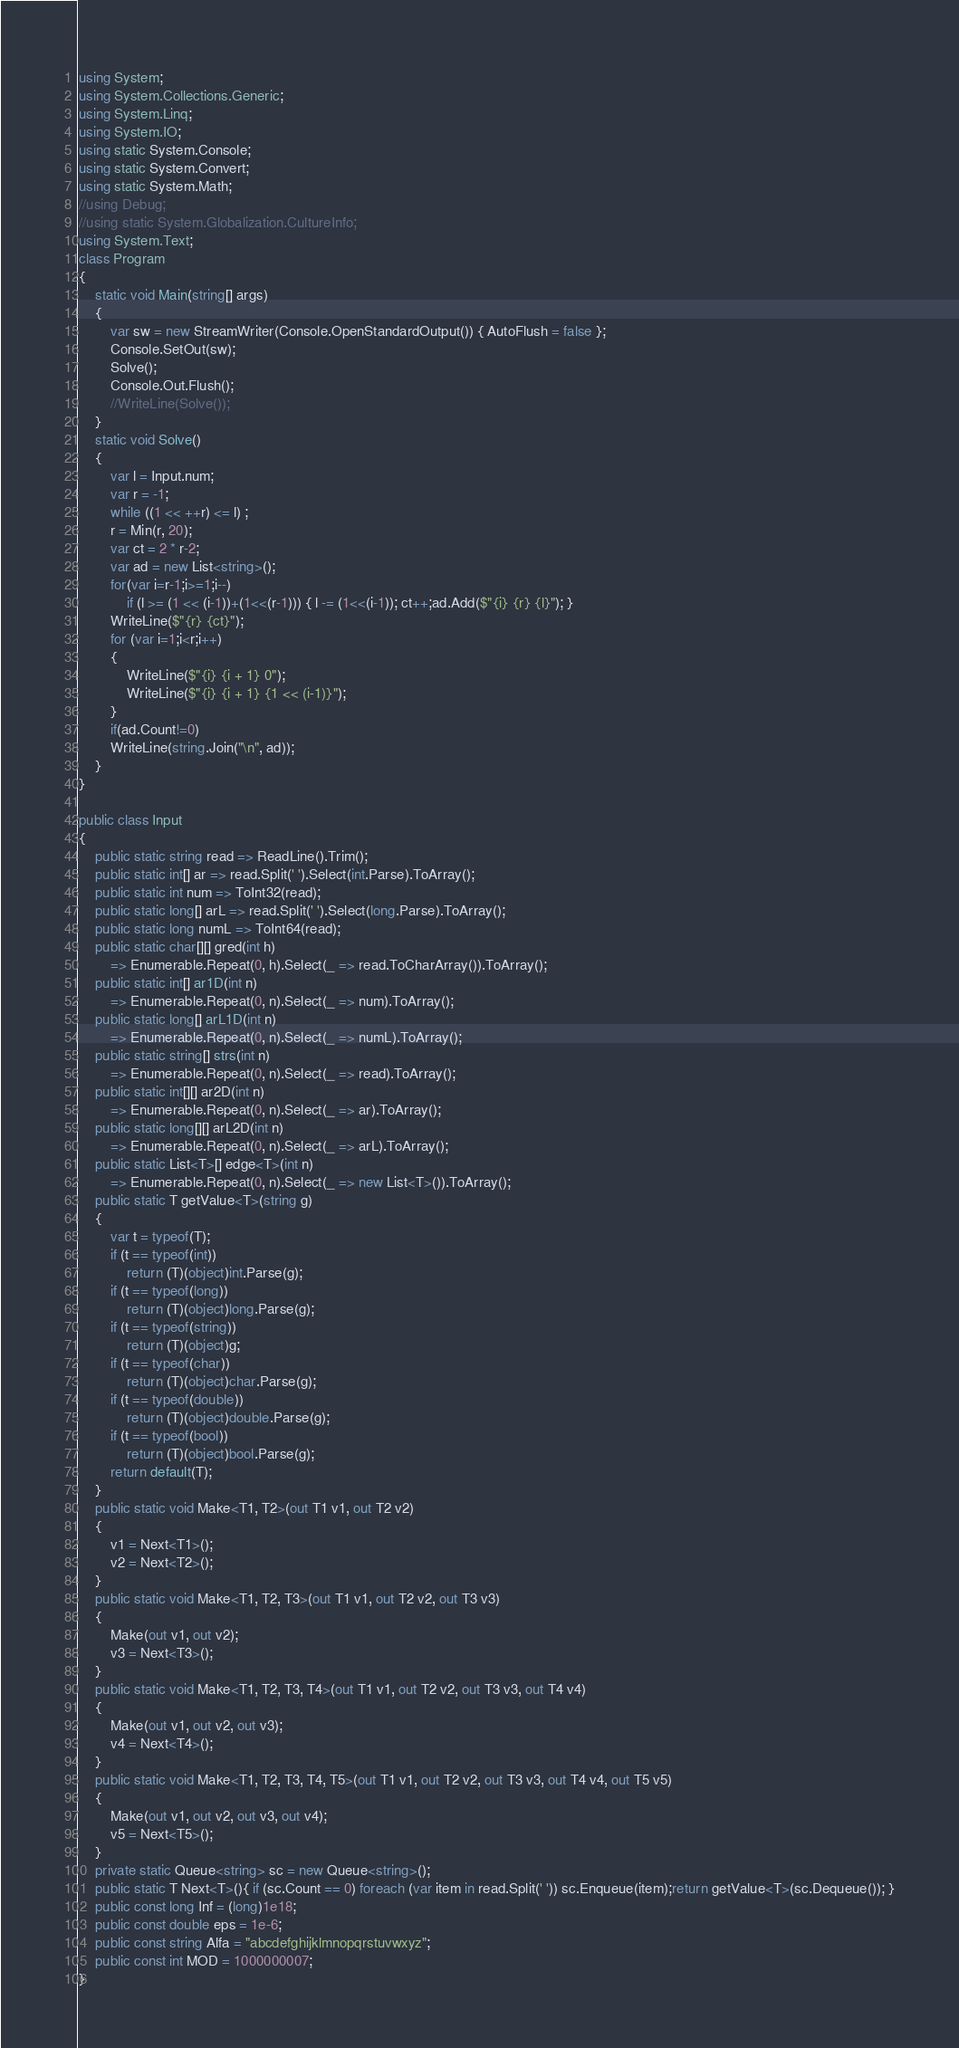<code> <loc_0><loc_0><loc_500><loc_500><_C#_>using System;
using System.Collections.Generic;
using System.Linq;
using System.IO;
using static System.Console;
using static System.Convert;
using static System.Math;
//using Debug;
//using static System.Globalization.CultureInfo;
using System.Text;
class Program
{
    static void Main(string[] args)
    {
        var sw = new StreamWriter(Console.OpenStandardOutput()) { AutoFlush = false };
        Console.SetOut(sw);
        Solve();
        Console.Out.Flush();
        //WriteLine(Solve());
    }
    static void Solve()
    {
        var l = Input.num;
        var r = -1;
        while ((1 << ++r) <= l) ;
        r = Min(r, 20);
        var ct = 2 * r-2;
        var ad = new List<string>();
        for(var i=r-1;i>=1;i--)
            if (l >= (1 << (i-1))+(1<<(r-1))) { l -= (1<<(i-1)); ct++;ad.Add($"{i} {r} {l}"); }
        WriteLine($"{r} {ct}");
        for (var i=1;i<r;i++)
        {
            WriteLine($"{i} {i + 1} 0");
            WriteLine($"{i} {i + 1} {1 << (i-1)}");
        }
        if(ad.Count!=0)
        WriteLine(string.Join("\n", ad));
    }
}

public class Input
{
    public static string read => ReadLine().Trim();
    public static int[] ar => read.Split(' ').Select(int.Parse).ToArray();
    public static int num => ToInt32(read);
    public static long[] arL => read.Split(' ').Select(long.Parse).ToArray();
    public static long numL => ToInt64(read);
    public static char[][] gred(int h)
        => Enumerable.Repeat(0, h).Select(_ => read.ToCharArray()).ToArray();
    public static int[] ar1D(int n)
        => Enumerable.Repeat(0, n).Select(_ => num).ToArray();
    public static long[] arL1D(int n)
        => Enumerable.Repeat(0, n).Select(_ => numL).ToArray();
    public static string[] strs(int n)
        => Enumerable.Repeat(0, n).Select(_ => read).ToArray();
    public static int[][] ar2D(int n)
        => Enumerable.Repeat(0, n).Select(_ => ar).ToArray();
    public static long[][] arL2D(int n)
        => Enumerable.Repeat(0, n).Select(_ => arL).ToArray();
    public static List<T>[] edge<T>(int n)
        => Enumerable.Repeat(0, n).Select(_ => new List<T>()).ToArray();
    public static T getValue<T>(string g)
    {
        var t = typeof(T);
        if (t == typeof(int))
            return (T)(object)int.Parse(g);
        if (t == typeof(long))
            return (T)(object)long.Parse(g);
        if (t == typeof(string))
            return (T)(object)g;
        if (t == typeof(char))
            return (T)(object)char.Parse(g);
        if (t == typeof(double))
            return (T)(object)double.Parse(g);
        if (t == typeof(bool))
            return (T)(object)bool.Parse(g);
        return default(T);
    }
    public static void Make<T1, T2>(out T1 v1, out T2 v2)
    {
        v1 = Next<T1>();
        v2 = Next<T2>();
    }
    public static void Make<T1, T2, T3>(out T1 v1, out T2 v2, out T3 v3)
    {
        Make(out v1, out v2);
        v3 = Next<T3>();
    }
    public static void Make<T1, T2, T3, T4>(out T1 v1, out T2 v2, out T3 v3, out T4 v4)
    {
        Make(out v1, out v2, out v3);
        v4 = Next<T4>();
    }
    public static void Make<T1, T2, T3, T4, T5>(out T1 v1, out T2 v2, out T3 v3, out T4 v4, out T5 v5)
    {
        Make(out v1, out v2, out v3, out v4);
        v5 = Next<T5>();
    }
    private static Queue<string> sc = new Queue<string>();
    public static T Next<T>(){ if (sc.Count == 0) foreach (var item in read.Split(' ')) sc.Enqueue(item);return getValue<T>(sc.Dequeue()); }
    public const long Inf = (long)1e18;
    public const double eps = 1e-6;
    public const string Alfa = "abcdefghijklmnopqrstuvwxyz";
    public const int MOD = 1000000007;
}
</code> 